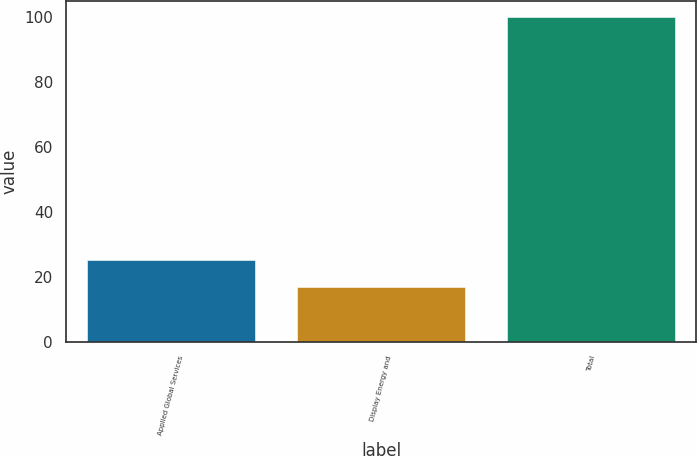<chart> <loc_0><loc_0><loc_500><loc_500><bar_chart><fcel>Applied Global Services<fcel>Display Energy and<fcel>Total<nl><fcel>25.3<fcel>17<fcel>100<nl></chart> 